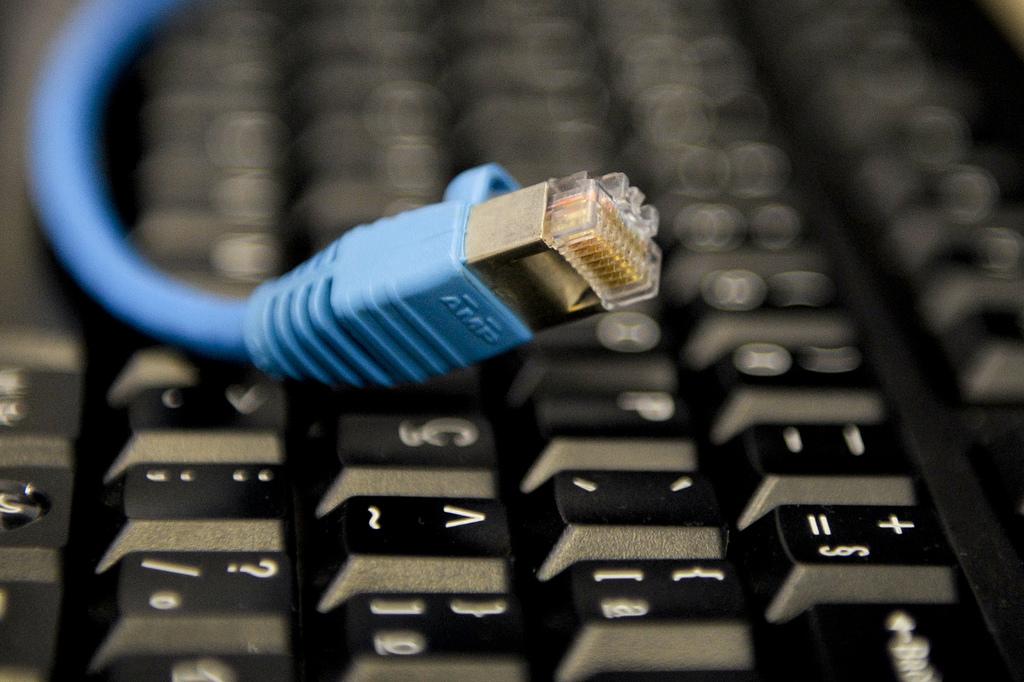What key is the wire laying on?
Your answer should be very brief. C. Is there a question mark shown?
Offer a very short reply. Yes. 